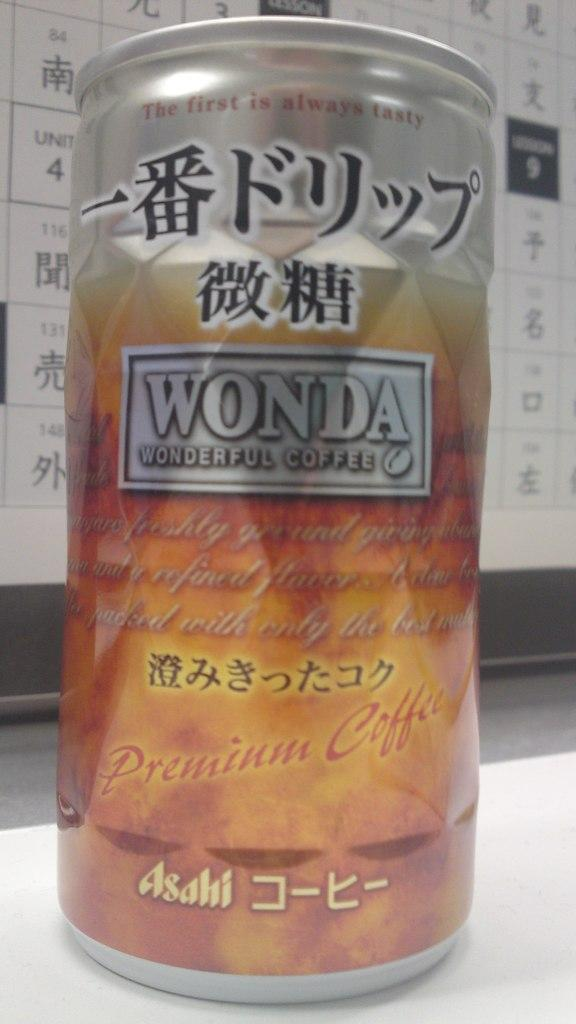<image>
Give a short and clear explanation of the subsequent image. A can of Wonda Wonderful Coffee sitting on a table in front of a calendar. 